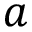Convert formula to latex. <formula><loc_0><loc_0><loc_500><loc_500>a</formula> 